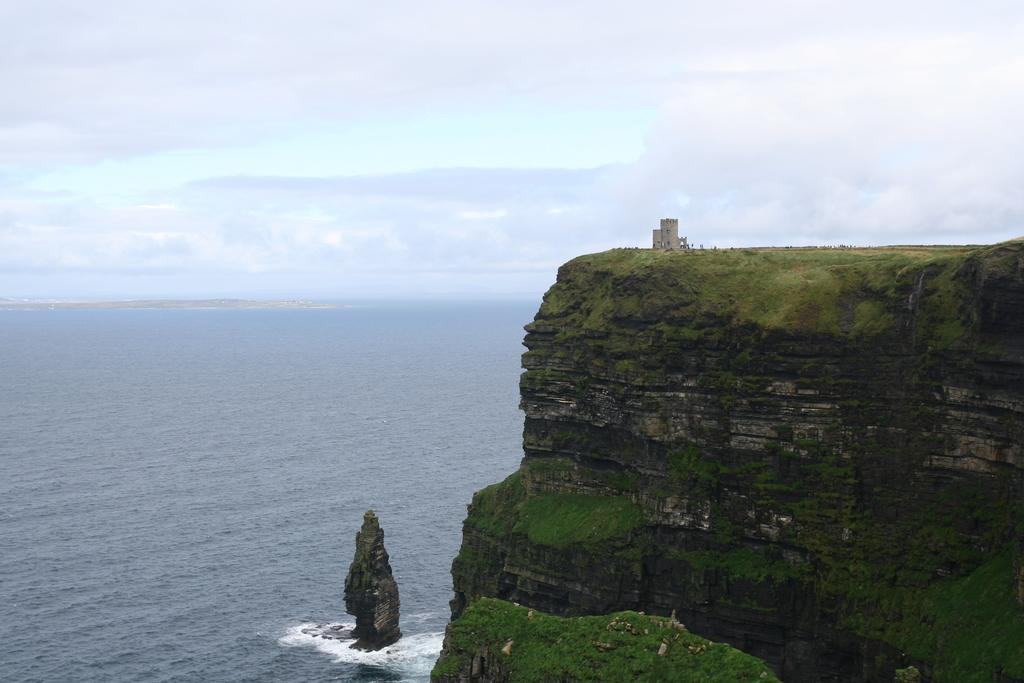What type of natural feature is present in the image? There is an ocean in the image. What other natural feature can be seen in the image? There is a mountain in the image. What is the condition of the sky in the image? The sky is covered with clouds. Where is the nest of the metal ornament located in the image? There is no nest or metal ornament present in the image. 